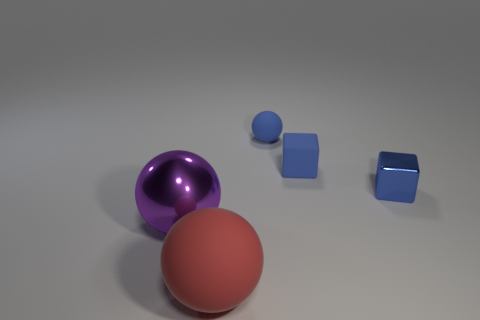There is a big sphere behind the red rubber ball; what is it made of?
Ensure brevity in your answer.  Metal. Does the red thing have the same shape as the purple object?
Keep it short and to the point. Yes. Is there anything else that has the same color as the shiny ball?
Give a very brief answer. No. What color is the other big shiny thing that is the same shape as the red object?
Your response must be concise. Purple. Is the number of balls right of the large rubber object greater than the number of large yellow cylinders?
Your answer should be very brief. Yes. The tiny rubber object that is in front of the small rubber sphere is what color?
Your response must be concise. Blue. Is the blue metallic block the same size as the red rubber thing?
Provide a short and direct response. No. The purple metal thing has what size?
Ensure brevity in your answer.  Large. There is a tiny matte thing that is the same color as the rubber cube; what is its shape?
Make the answer very short. Sphere. Are there more tiny blue metal cubes than tiny matte objects?
Keep it short and to the point. No. 